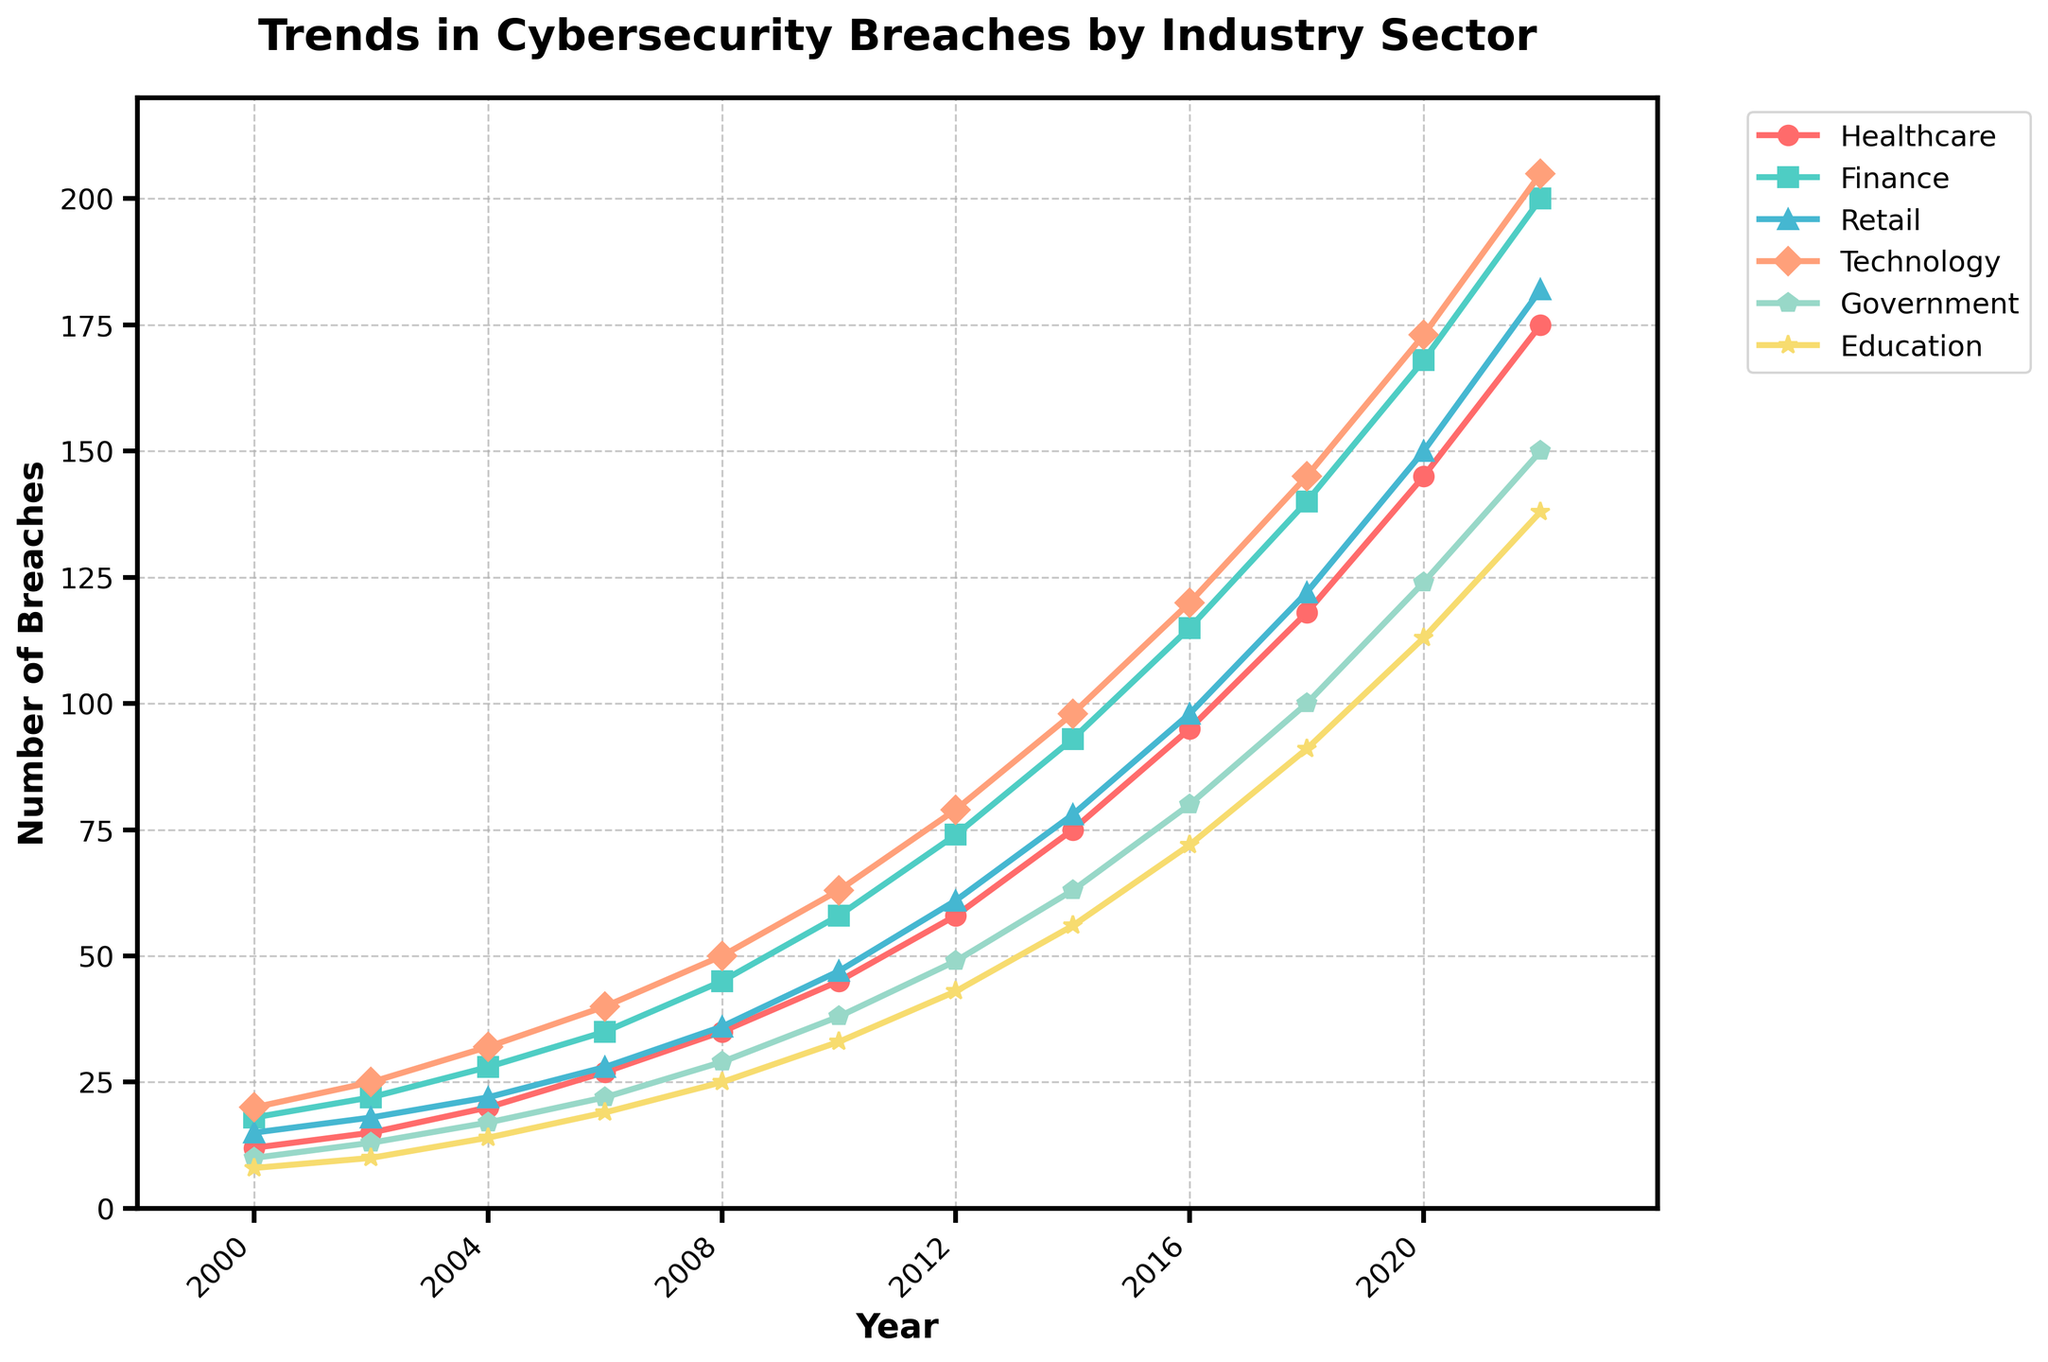What's the overall trend in cybersecurity breaches from 2000 to 2022? The overall trend for all industry sectors shows an increase. Each sector's line rises steadily from 2000 to 2022, indicating that breaches have been growing over time.
Answer: Increasing Which industry sector experienced the most breaches in 2022? In 2022, the sector showing the highest number of breaches on the rightmost end of the plot is Finance.
Answer: Finance Between which consecutive years did the Retail sector see the largest increase in breaches? To determine this, compare the increases between each pair of consecutive years for Retail. The sector increases as follows: 3 (2000-2002), 4 (2002-2004), 6 (2004-2006), 8 (2006-2008), 11 (2008-2010), 14 (2010-2012), 17 (2012-2014), 20 (2014-2016), 24 (2016-2018), 28 (2018-2020), and 32 (2020-2022). The largest increase is 32 between 2020 and 2022.
Answer: 2020-2022 In 2014, how did the number of breaches in the Healthcare sector compare to the Education sector? In 2014, the line for Healthcare is at 75 breaches and for Education at 56 breaches. Therefore, Healthcare had more breaches than Education in 2014.
Answer: Healthcare had more By how much did breaches in the Government sector increase between 2000 and 2022? Calculate the difference by subtracting the Government breaches in 2000 (10) from those in 2022 (150), which gives 150 - 10 = 140.
Answer: 140 On the plot, which industry's breaches increased most rapidly between 2000 and 2008? Between 2000 and 2008, the Finance sector's line rises the steepest compared to other sectors.
Answer: Finance Which sector showed the least number of breaches in 2020, and what was the count? In 2020, the Education sector, represented by the lowest line, had 113 breaches, the least among all sectors.
Answer: Education, 113 What is the average number of government sector breaches from 2000 to 2022? Sum the breaches for Government (10, 13, 17, 22, 29, 38, 49, 63, 80, 100, 124, 150) which totals 695, and then divide by the number of years, which is 12. The average is 695 / 12 ≈ 57.92.
Answer: 57.92 Between 2014 and 2018, which sector saw the largest absolute increase in breaches? Calculate the increase for each sector between 2014 and 2018: Healthcare (43), Finance (47), Retail (44), Technology (47), Government (37), Education (35). The Finance and Technology sectors both saw the largest increase with 47 breaches.
Answer: Finance and Technology 